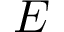Convert formula to latex. <formula><loc_0><loc_0><loc_500><loc_500>E</formula> 